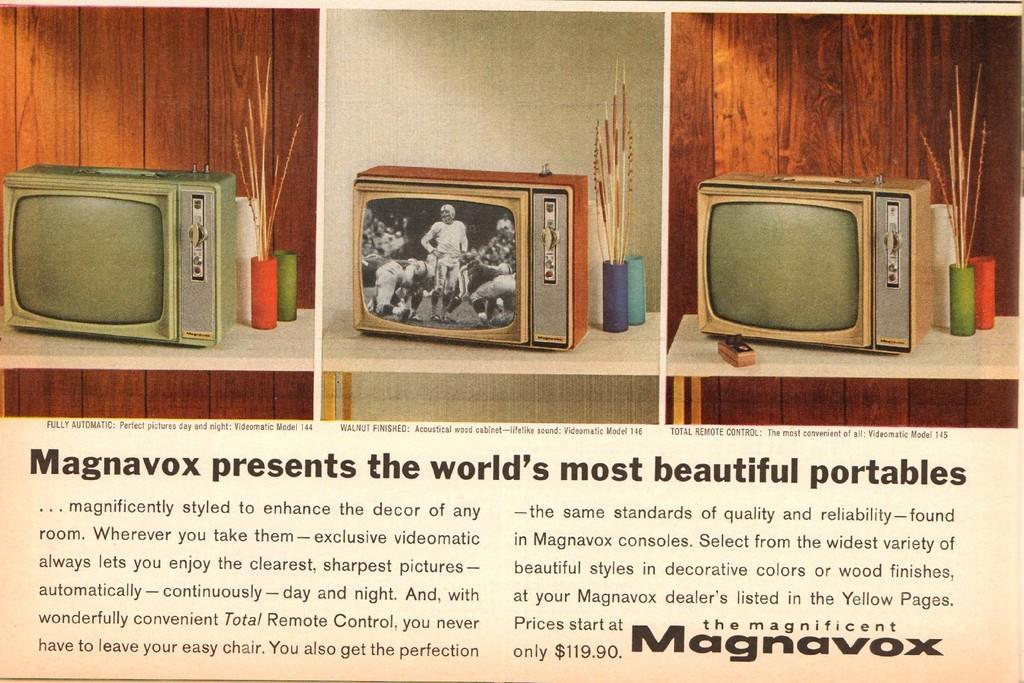Provide a one-sentence caption for the provided image. An old article about the magnificent Magnavox portables. 